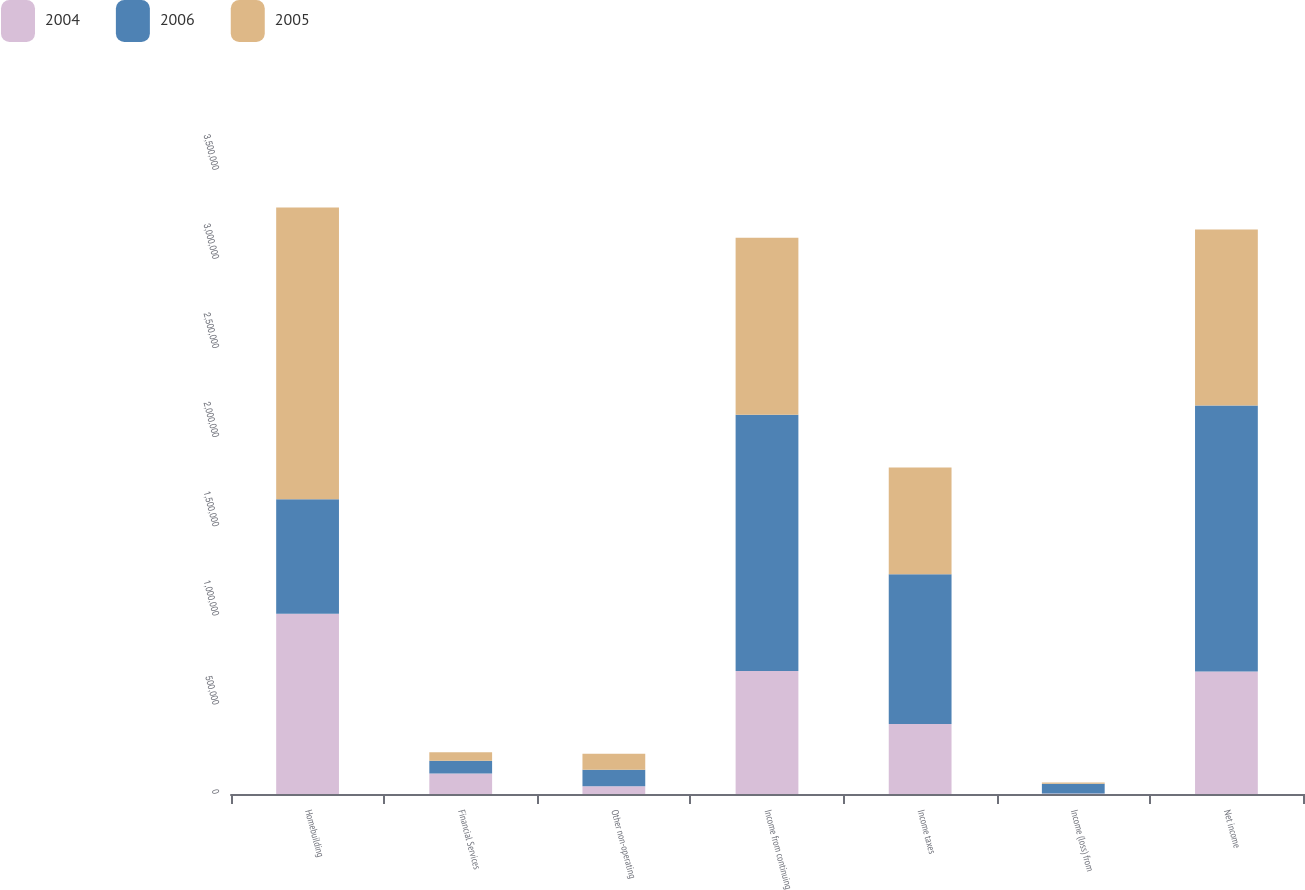Convert chart. <chart><loc_0><loc_0><loc_500><loc_500><stacked_bar_chart><ecel><fcel>Homebuilding<fcel>Financial Services<fcel>Other non-operating<fcel>Income from continuing<fcel>Income taxes<fcel>Income (loss) from<fcel>Net income<nl><fcel>2004<fcel>1.01037e+06<fcel>115460<fcel>43100<fcel>689646<fcel>393082<fcel>2175<fcel>687471<nl><fcel>2006<fcel>643111<fcel>70586<fcel>92394<fcel>1.43689e+06<fcel>840126<fcel>55025<fcel>1.49191e+06<nl><fcel>2005<fcel>1.63558e+06<fcel>47429<fcel>90685<fcel>993573<fcel>598751<fcel>7032<fcel>986541<nl></chart> 